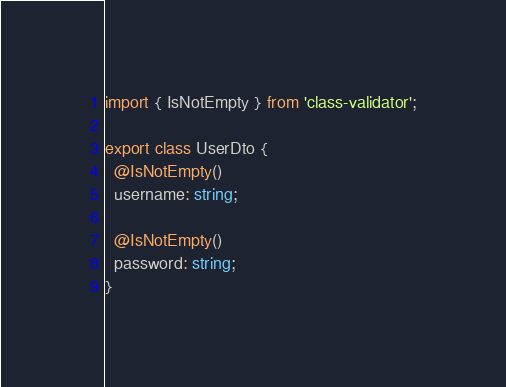<code> <loc_0><loc_0><loc_500><loc_500><_TypeScript_>import { IsNotEmpty } from 'class-validator';

export class UserDto {
  @IsNotEmpty()
  username: string;

  @IsNotEmpty()
  password: string;
}</code> 